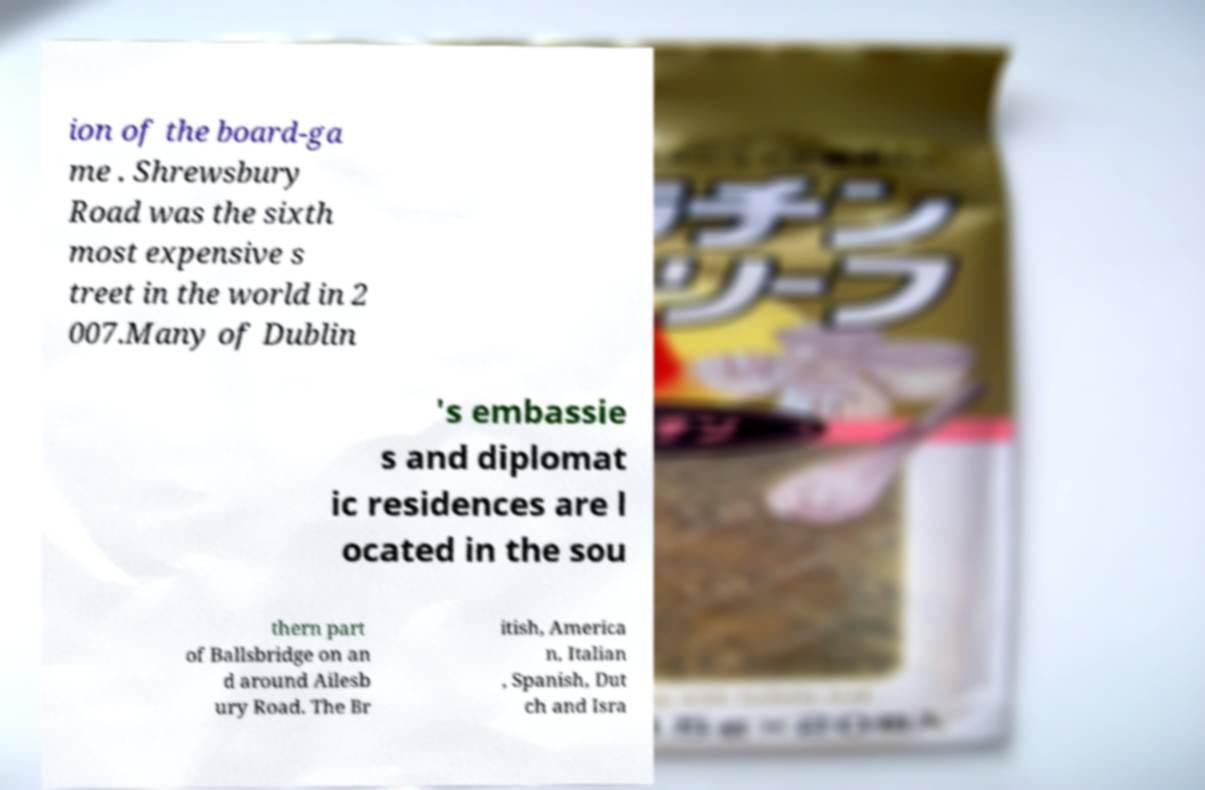Please identify and transcribe the text found in this image. ion of the board-ga me . Shrewsbury Road was the sixth most expensive s treet in the world in 2 007.Many of Dublin 's embassie s and diplomat ic residences are l ocated in the sou thern part of Ballsbridge on an d around Ailesb ury Road. The Br itish, America n, Italian , Spanish, Dut ch and Isra 